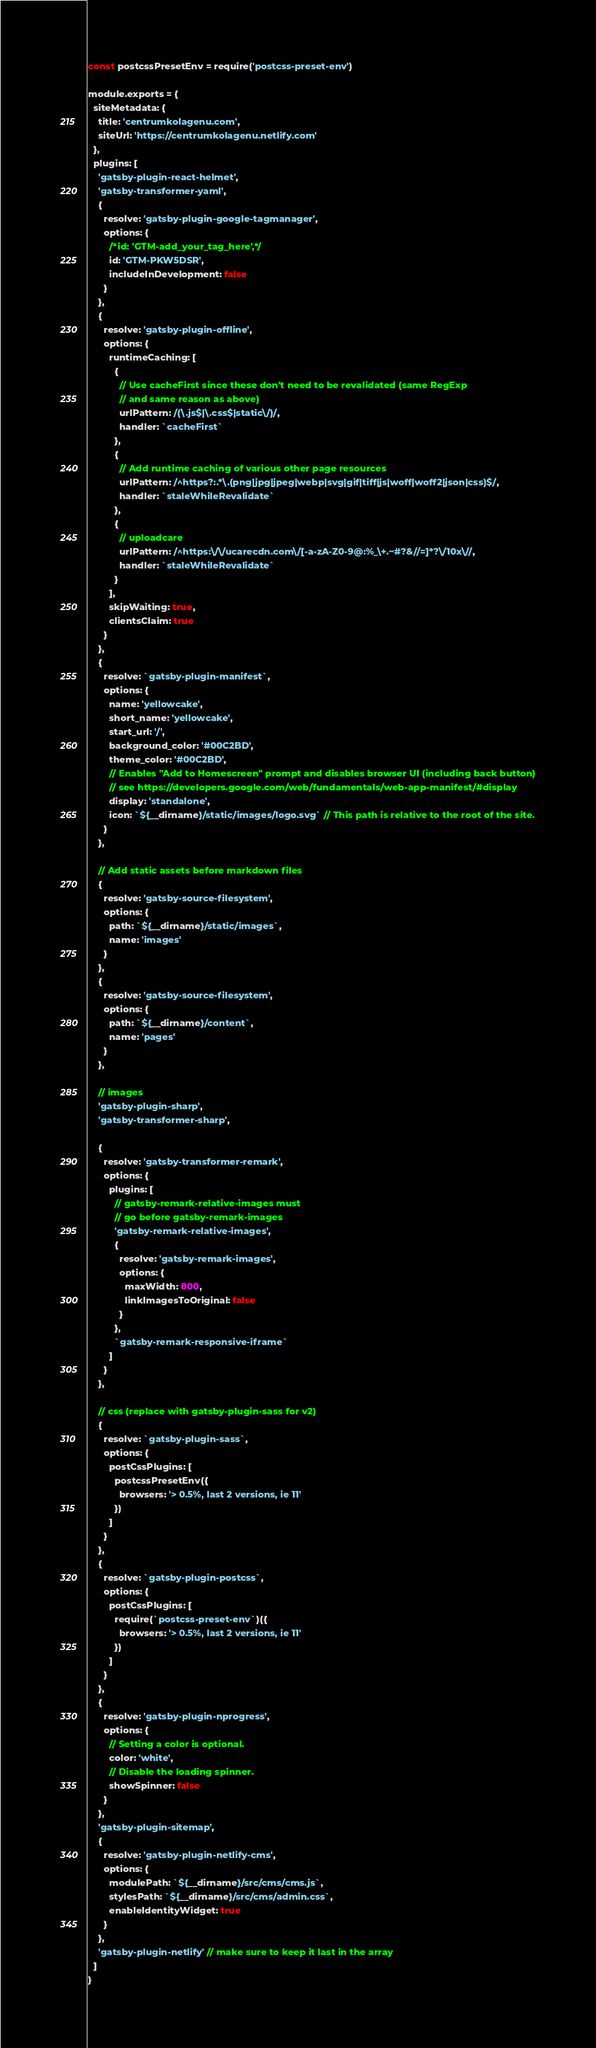Convert code to text. <code><loc_0><loc_0><loc_500><loc_500><_JavaScript_>const postcssPresetEnv = require('postcss-preset-env')

module.exports = {
  siteMetadata: {
    title: 'centrumkolagenu.com',
    siteUrl: 'https://centrumkolagenu.netlify.com'
  },
  plugins: [
    'gatsby-plugin-react-helmet',
    'gatsby-transformer-yaml',
    {
      resolve: 'gatsby-plugin-google-tagmanager',
      options: {
        /*id: 'GTM-add_your_tag_here',*/
        id: 'GTM-PKW5DSR',
        includeInDevelopment: false
      }
    },
    {
      resolve: 'gatsby-plugin-offline',
      options: {
        runtimeCaching: [
          {
            // Use cacheFirst since these don't need to be revalidated (same RegExp
            // and same reason as above)
            urlPattern: /(\.js$|\.css$|static\/)/,
            handler: `cacheFirst`
          },
          {
            // Add runtime caching of various other page resources
            urlPattern: /^https?:.*\.(png|jpg|jpeg|webp|svg|gif|tiff|js|woff|woff2|json|css)$/,
            handler: `staleWhileRevalidate`
          },
          {
            // uploadcare
            urlPattern: /^https:\/\/ucarecdn.com\/[-a-zA-Z0-9@:%_\+.~#?&//=]*?\/10x\//,
            handler: `staleWhileRevalidate`
          }
        ],
        skipWaiting: true,
        clientsClaim: true
      }
    },
    {
      resolve: `gatsby-plugin-manifest`,
      options: {
        name: 'yellowcake',
        short_name: 'yellowcake',
        start_url: '/',
        background_color: '#00C2BD',
        theme_color: '#00C2BD',
        // Enables "Add to Homescreen" prompt and disables browser UI (including back button)
        // see https://developers.google.com/web/fundamentals/web-app-manifest/#display
        display: 'standalone',
        icon: `${__dirname}/static/images/logo.svg` // This path is relative to the root of the site.
      }
    },

    // Add static assets before markdown files
    {
      resolve: 'gatsby-source-filesystem',
      options: {
        path: `${__dirname}/static/images`,
        name: 'images'
      }
    },
    {
      resolve: 'gatsby-source-filesystem',
      options: {
        path: `${__dirname}/content`,
        name: 'pages'
      }
    },

    // images
    'gatsby-plugin-sharp',
    'gatsby-transformer-sharp',

    {
      resolve: 'gatsby-transformer-remark',
      options: {
        plugins: [
          // gatsby-remark-relative-images must
          // go before gatsby-remark-images
          'gatsby-remark-relative-images',
          {
            resolve: 'gatsby-remark-images',
            options: {
              maxWidth: 800,
              linkImagesToOriginal: false
            }
          },
          `gatsby-remark-responsive-iframe`
        ]
      }
    },

    // css (replace with gatsby-plugin-sass for v2)
    {
      resolve: `gatsby-plugin-sass`,
      options: {
        postCssPlugins: [
          postcssPresetEnv({
            browsers: '> 0.5%, last 2 versions, ie 11'
          })
        ]
      }
    },
    {
      resolve: `gatsby-plugin-postcss`,
      options: {
        postCssPlugins: [
          require(`postcss-preset-env`)({
            browsers: '> 0.5%, last 2 versions, ie 11'
          })
        ]
      }
    },
    {
      resolve: 'gatsby-plugin-nprogress',
      options: {
        // Setting a color is optional.
        color: 'white',
        // Disable the loading spinner.
        showSpinner: false
      }
    },
    'gatsby-plugin-sitemap',
    {
      resolve: 'gatsby-plugin-netlify-cms',
      options: {
        modulePath: `${__dirname}/src/cms/cms.js`,
        stylesPath: `${__dirname}/src/cms/admin.css`,
        enableIdentityWidget: true
      }
    },
    'gatsby-plugin-netlify' // make sure to keep it last in the array
  ]
}
</code> 